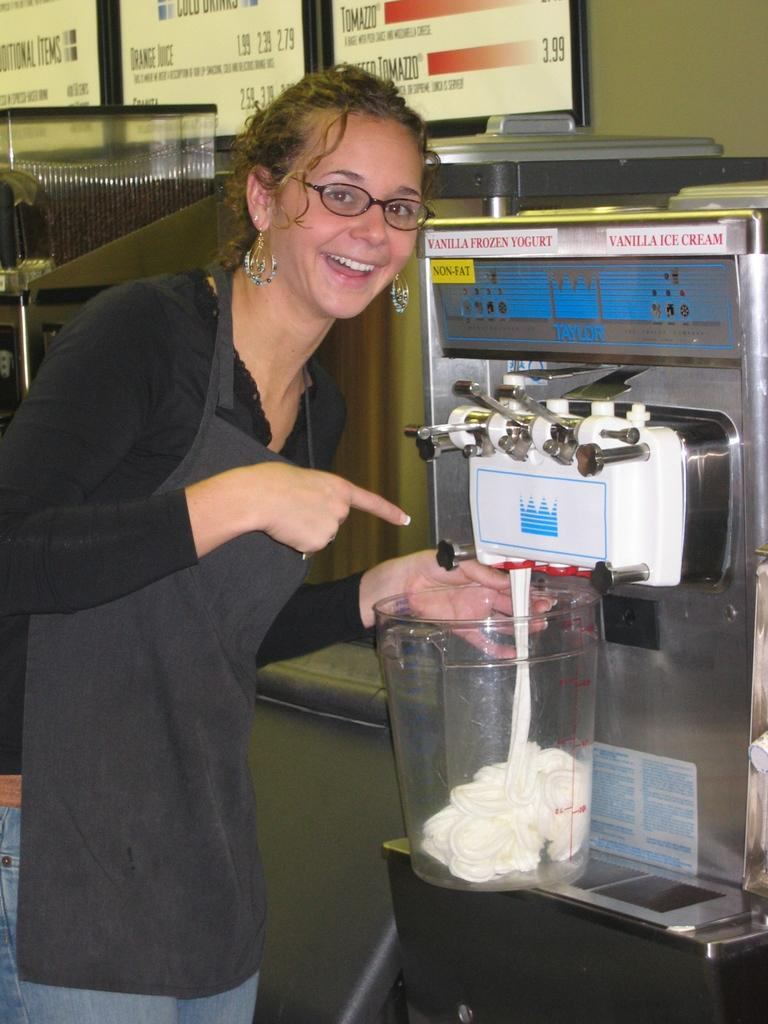<image>
Share a concise interpretation of the image provided. A woman fills a large container from a vanilla ice cream and yogurt machine. 